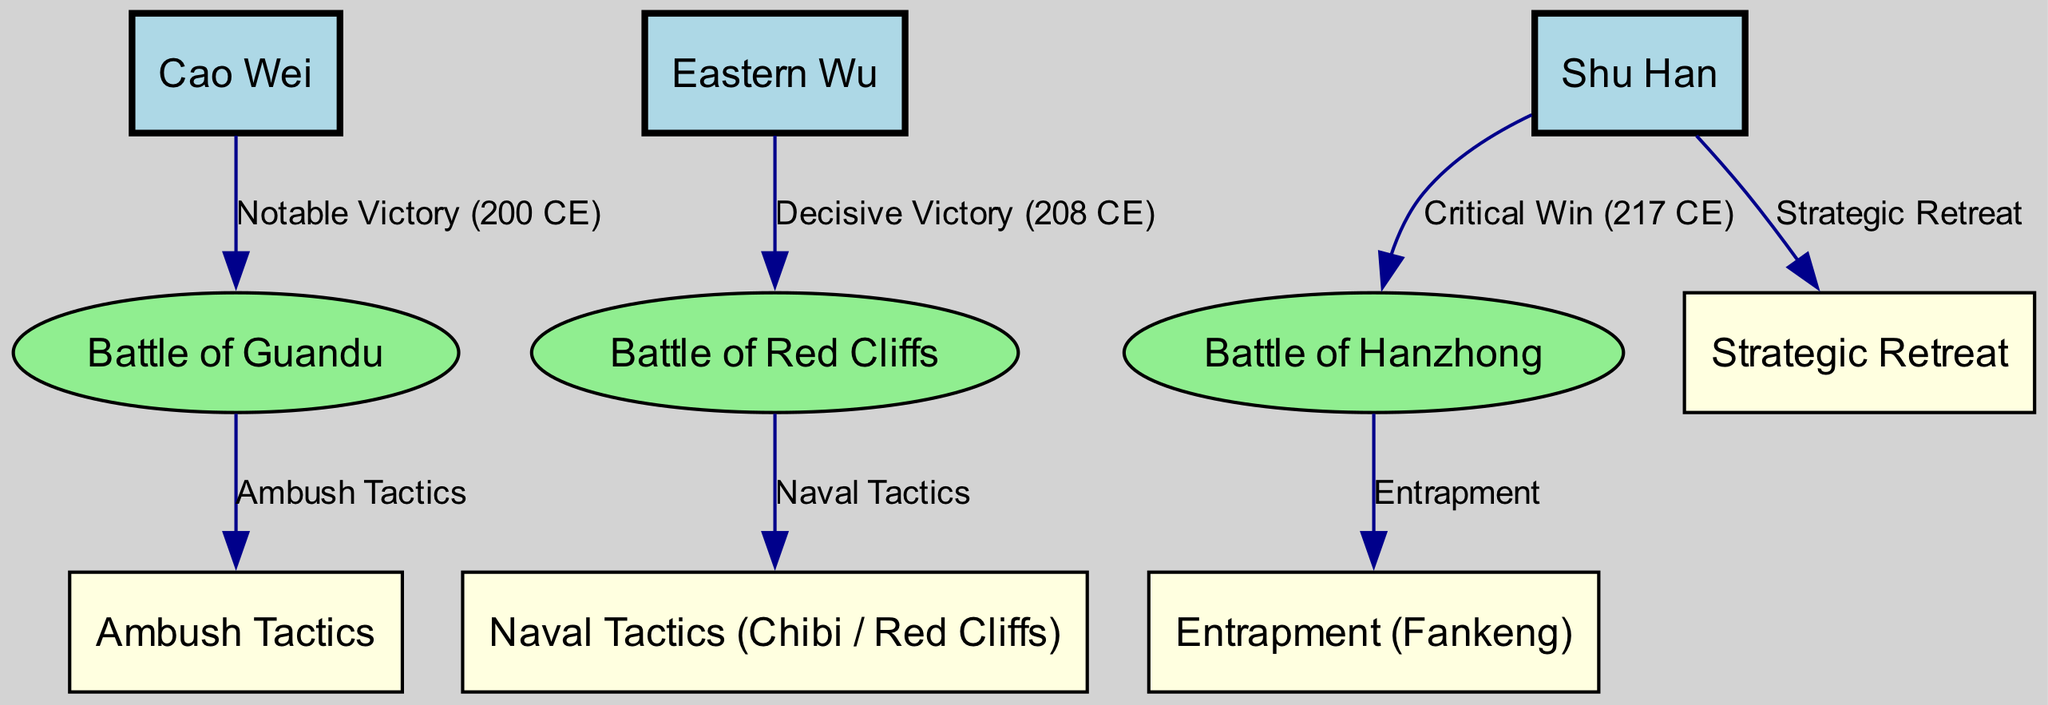What are the three kingdoms represented in the diagram? The diagram explicitly labels the three kingdoms as nodes: Cao Wei, Eastern Wu, and Shu Han. These nodes are prominently displayed at the top of the diagram.
Answer: Cao Wei, Eastern Wu, Shu Han Which battle is associated with a notable victory for Cao Wei? The edge connecting Cao Wei to the Battle of Guandu indicates it was a notable victory in the year 200 CE, according to the label of the edge.
Answer: Battle of Guandu How many battles are featured in the diagram? By counting the battle nodes, we see that there are three unique battle nodes: Guandu, Red Cliffs, and Hanzhong. Therefore, the total number of battles is three.
Answer: 3 What tactic is linked to the Battle of Red Cliffs? The edge from the Battle of Red Cliffs to the naval tactics node indicates a relationship, as it is labeled with "Naval Tactics," showing the strategy associated with that battle.
Answer: Naval Tactics Which kingdom employed ambush tactics? The edge from Cao Wei to the Ambush Tactics node specifies that Cao Wei implemented this strategy, showing the direct relationship between them in the diagram.
Answer: Cao Wei What is the result of the Battle of Hanzhong? The label on the edge connecting Shu Han to Hanzhong states it was a "Critical Win" in 217 CE, indicating the outcome of that battle for the Shu Han kingdom.
Answer: Critical Win What strategy did Shu Han utilize according to the diagram? The edge leading from Shu Han to the Strategic Retreat node clearly indicates that Shu Han employed this approach in their military engagements, establishing a direct connection.
Answer: Strategic Retreat How is the Entrapment tactic connected to Hanzhong? The edge from Hanzhong to the Entrapment tactic node highlights that this battle involved the entrapment strategy, demonstrating a tactical decision made during this conflict.
Answer: Entrapment Which kingdom achieved a decisive victory at the Battle of Red Cliffs? The edge leading from Eastern Wu to the Battle of Red Cliffs notes it as a "Decisive Victory" in the year 208 CE, clearly identifying Eastern Wu's success.
Answer: Eastern Wu 